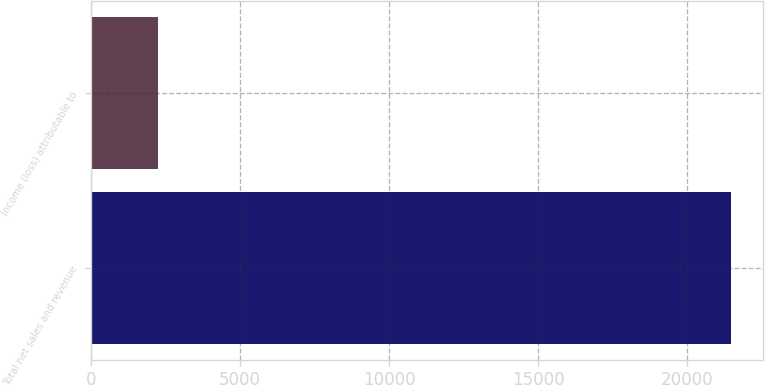Convert chart. <chart><loc_0><loc_0><loc_500><loc_500><bar_chart><fcel>Total net sales and revenue<fcel>Income (loss) attributable to<nl><fcel>21470<fcel>2262<nl></chart> 